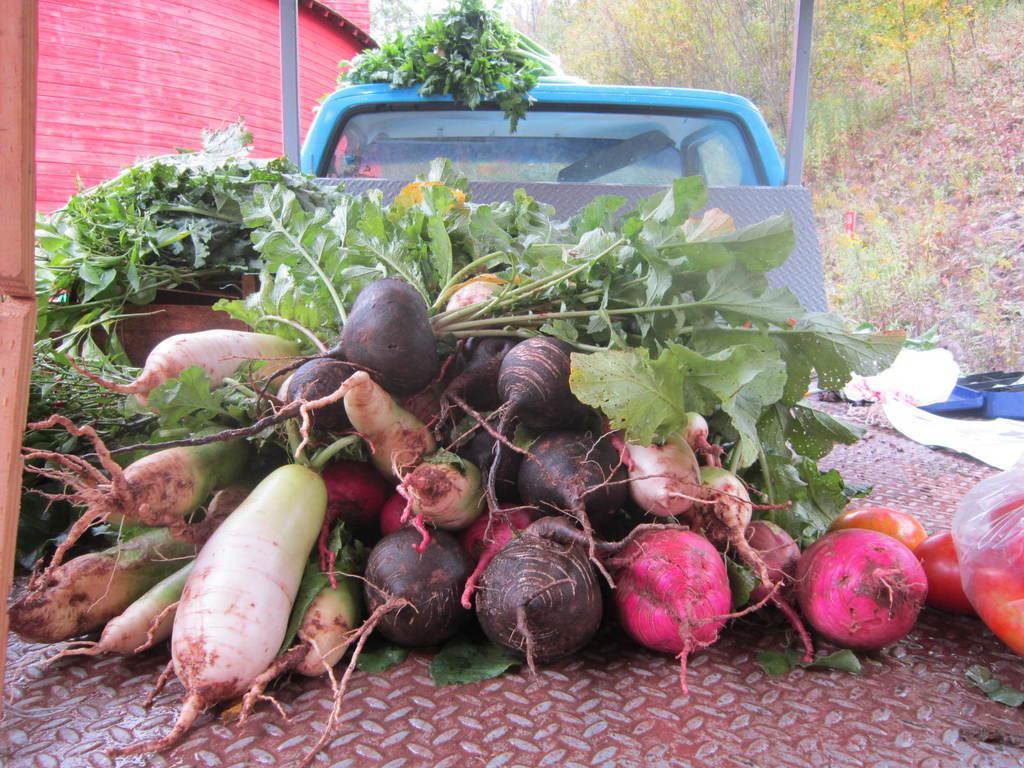Please provide a concise description of this image. In this image we can see a vehicle loaded with vegetables. At the bottom there is an iron sheet. In the background there are trees, poles and a building. 